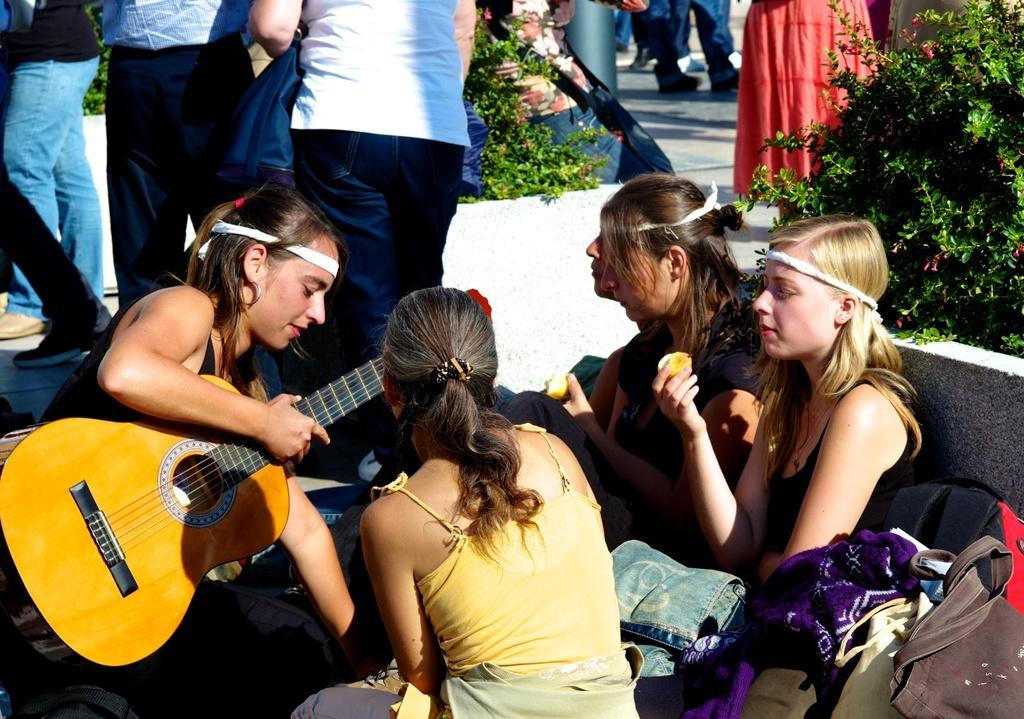How would you summarize this image in a sentence or two? This is an outdoor picture. Here we can see flower plants. Here we can see women sitting and she is holding a guitar in her hand and few are eating. These are bags. We can see all the persons standing and walking on the background. 